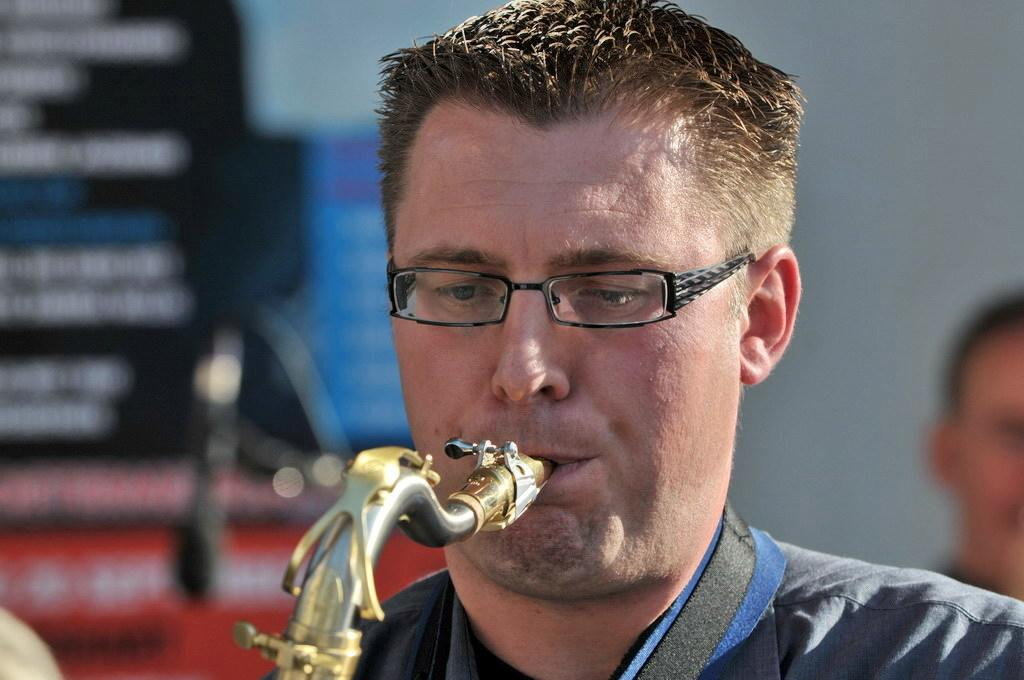What is the man in the image doing? The man is playing a musical instrument in the image. Can you describe the man's appearance? The man is wearing spectacles in the image. Is there anyone else in the image besides the man? Yes, there is a person in the background of the image. How is the person in the background depicted? The person in the background is blurred in the image. How many cows can be seen in the background of the image? There are no cows present in the image; it only features a man playing a musical instrument and a blurred person in the background. 